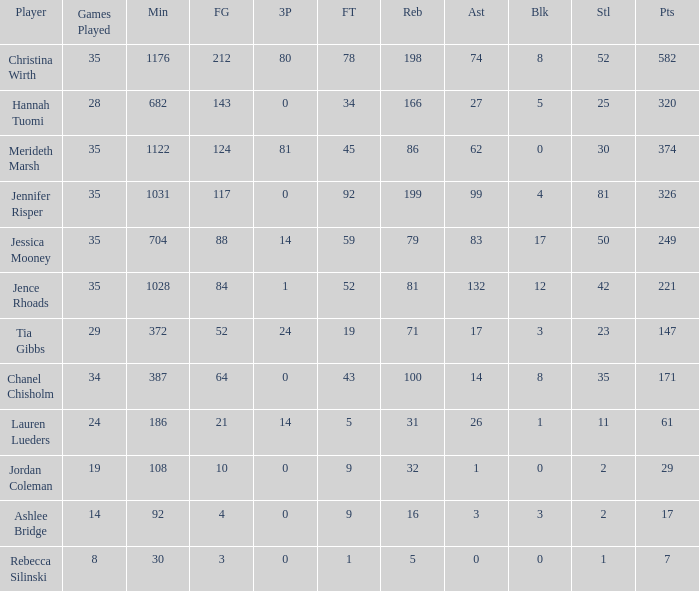How many blockings occured in the game with 198 rebounds? 8.0. 